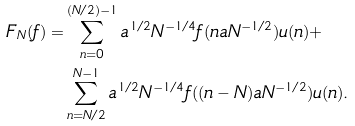Convert formula to latex. <formula><loc_0><loc_0><loc_500><loc_500>F _ { N } ( f ) = & \sum _ { n = 0 } ^ { ( N / 2 ) - 1 } a ^ { 1 / 2 } N ^ { - 1 / 4 } f ( n a N ^ { - 1 / 2 } ) u ( n ) + \\ & \sum _ { n = N / 2 } ^ { N - 1 } a ^ { 1 / 2 } N ^ { - 1 / 4 } f ( ( n - N ) a N ^ { - 1 / 2 } ) u ( n ) .</formula> 